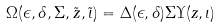<formula> <loc_0><loc_0><loc_500><loc_500>\Omega ( \epsilon , \delta , \Sigma , \tilde { z } , \tilde { \iota } ) = \Delta ( \epsilon , \delta ) \Sigma \Upsilon ( z , \iota )</formula> 